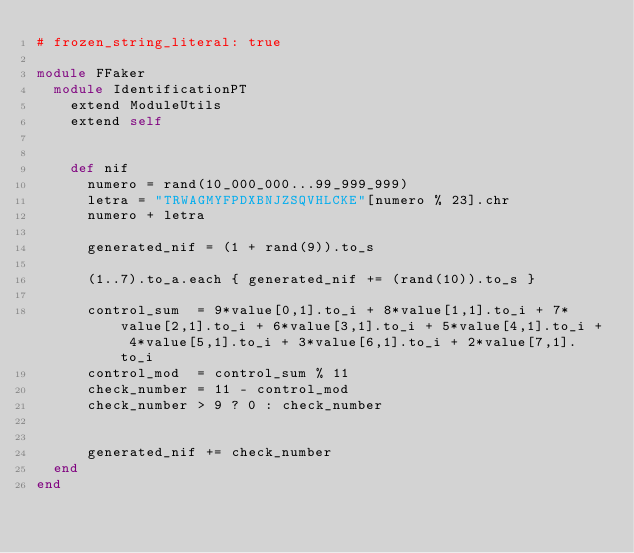<code> <loc_0><loc_0><loc_500><loc_500><_Ruby_># frozen_string_literal: true

module FFaker
  module IdentificationPT
    extend ModuleUtils
    extend self


    def nif
      numero = rand(10_000_000...99_999_999)
      letra = "TRWAGMYFPDXBNJZSQVHLCKE"[numero % 23].chr
      numero + letra

      generated_nif = (1 + rand(9)).to_s

      (1..7).to_a.each { generated_nif += (rand(10)).to_s }

      control_sum  = 9*value[0,1].to_i + 8*value[1,1].to_i + 7*value[2,1].to_i + 6*value[3,1].to_i + 5*value[4,1].to_i + 4*value[5,1].to_i + 3*value[6,1].to_i + 2*value[7,1].to_i
      control_mod  = control_sum % 11
      check_number = 11 - control_mod
      check_number > 9 ? 0 : check_number


      generated_nif += check_number
  end
end
</code> 